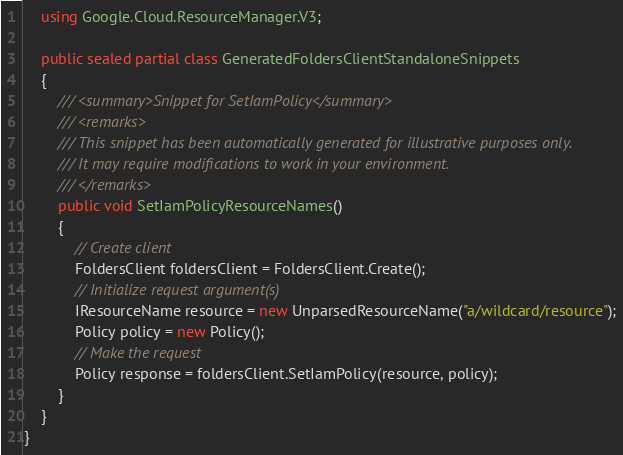Convert code to text. <code><loc_0><loc_0><loc_500><loc_500><_C#_>    using Google.Cloud.ResourceManager.V3;

    public sealed partial class GeneratedFoldersClientStandaloneSnippets
    {
        /// <summary>Snippet for SetIamPolicy</summary>
        /// <remarks>
        /// This snippet has been automatically generated for illustrative purposes only.
        /// It may require modifications to work in your environment.
        /// </remarks>
        public void SetIamPolicyResourceNames()
        {
            // Create client
            FoldersClient foldersClient = FoldersClient.Create();
            // Initialize request argument(s)
            IResourceName resource = new UnparsedResourceName("a/wildcard/resource");
            Policy policy = new Policy();
            // Make the request
            Policy response = foldersClient.SetIamPolicy(resource, policy);
        }
    }
}
</code> 